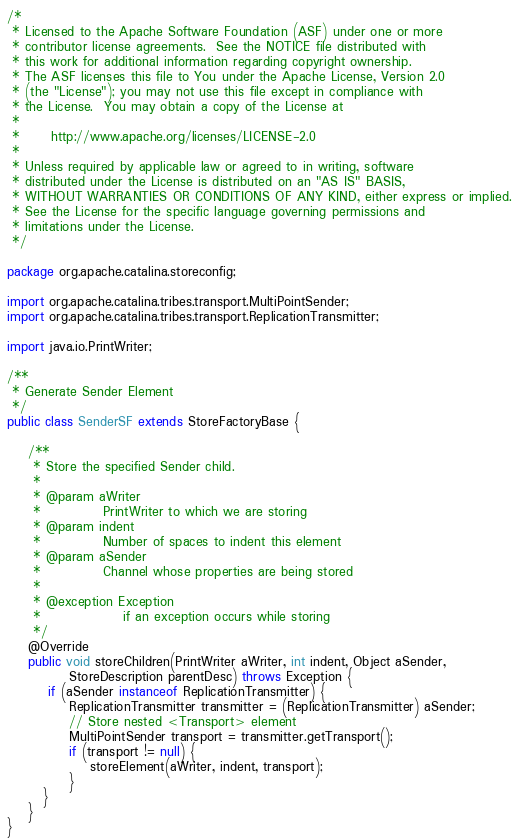<code> <loc_0><loc_0><loc_500><loc_500><_Java_>/*
 * Licensed to the Apache Software Foundation (ASF) under one or more
 * contributor license agreements.  See the NOTICE file distributed with
 * this work for additional information regarding copyright ownership.
 * The ASF licenses this file to You under the Apache License, Version 2.0
 * (the "License"); you may not use this file except in compliance with
 * the License.  You may obtain a copy of the License at
 *
 *      http://www.apache.org/licenses/LICENSE-2.0
 *
 * Unless required by applicable law or agreed to in writing, software
 * distributed under the License is distributed on an "AS IS" BASIS,
 * WITHOUT WARRANTIES OR CONDITIONS OF ANY KIND, either express or implied.
 * See the License for the specific language governing permissions and
 * limitations under the License.
 */

package org.apache.catalina.storeconfig;

import org.apache.catalina.tribes.transport.MultiPointSender;
import org.apache.catalina.tribes.transport.ReplicationTransmitter;

import java.io.PrintWriter;

/**
 * Generate Sender Element
 */
public class SenderSF extends StoreFactoryBase {

    /**
     * Store the specified Sender child.
     *
     * @param aWriter
     *            PrintWriter to which we are storing
     * @param indent
     *            Number of spaces to indent this element
     * @param aSender
     *            Channel whose properties are being stored
     *
     * @exception Exception
     *                if an exception occurs while storing
     */
    @Override
    public void storeChildren(PrintWriter aWriter, int indent, Object aSender,
            StoreDescription parentDesc) throws Exception {
        if (aSender instanceof ReplicationTransmitter) {
            ReplicationTransmitter transmitter = (ReplicationTransmitter) aSender;
            // Store nested <Transport> element
            MultiPointSender transport = transmitter.getTransport();
            if (transport != null) {
                storeElement(aWriter, indent, transport);
            }
       }
    }
}</code> 